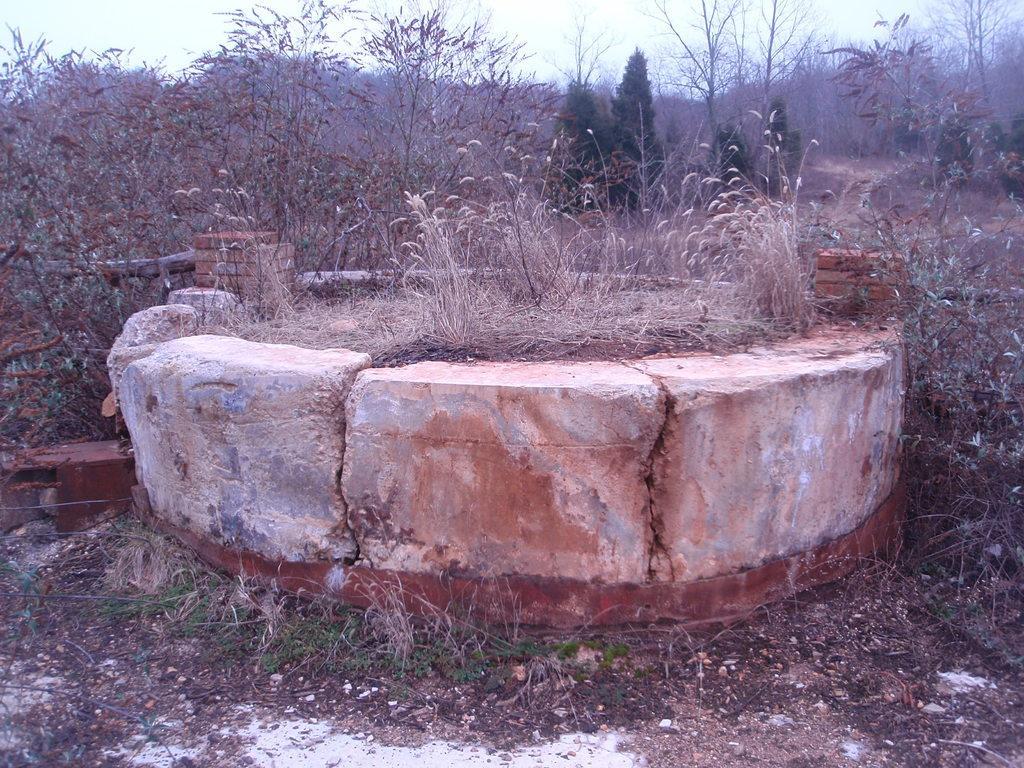Could you give a brief overview of what you see in this image? In this picture we can see a circular stone wall and on the wall there are bricks. On the left side of the circular stone wall there is a wooden log. Behind the bricks there are plants, trees and the sky. 